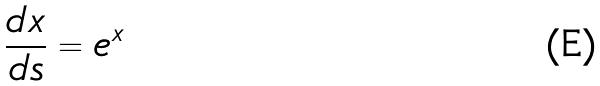<formula> <loc_0><loc_0><loc_500><loc_500>\frac { d x } { d s } = e ^ { x }</formula> 